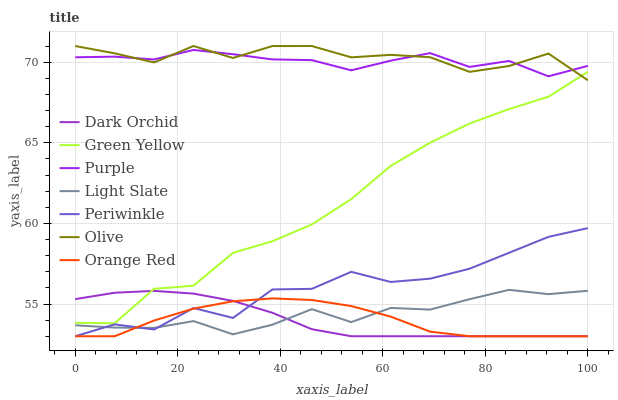Does Orange Red have the minimum area under the curve?
Answer yes or no. Yes. Does Olive have the maximum area under the curve?
Answer yes or no. Yes. Does Dark Orchid have the minimum area under the curve?
Answer yes or no. No. Does Dark Orchid have the maximum area under the curve?
Answer yes or no. No. Is Dark Orchid the smoothest?
Answer yes or no. Yes. Is Periwinkle the roughest?
Answer yes or no. Yes. Is Light Slate the smoothest?
Answer yes or no. No. Is Light Slate the roughest?
Answer yes or no. No. Does Dark Orchid have the lowest value?
Answer yes or no. Yes. Does Light Slate have the lowest value?
Answer yes or no. No. Does Olive have the highest value?
Answer yes or no. Yes. Does Dark Orchid have the highest value?
Answer yes or no. No. Is Dark Orchid less than Olive?
Answer yes or no. Yes. Is Olive greater than Periwinkle?
Answer yes or no. Yes. Does Olive intersect Purple?
Answer yes or no. Yes. Is Olive less than Purple?
Answer yes or no. No. Is Olive greater than Purple?
Answer yes or no. No. Does Dark Orchid intersect Olive?
Answer yes or no. No. 